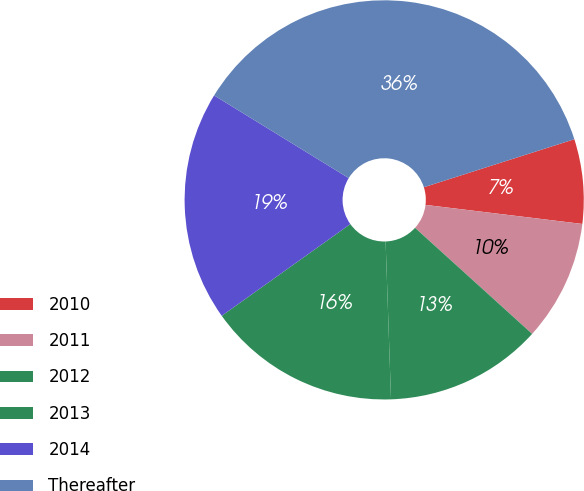<chart> <loc_0><loc_0><loc_500><loc_500><pie_chart><fcel>2010<fcel>2011<fcel>2012<fcel>2013<fcel>2014<fcel>Thereafter<nl><fcel>6.84%<fcel>9.79%<fcel>12.74%<fcel>15.68%<fcel>18.63%<fcel>36.32%<nl></chart> 